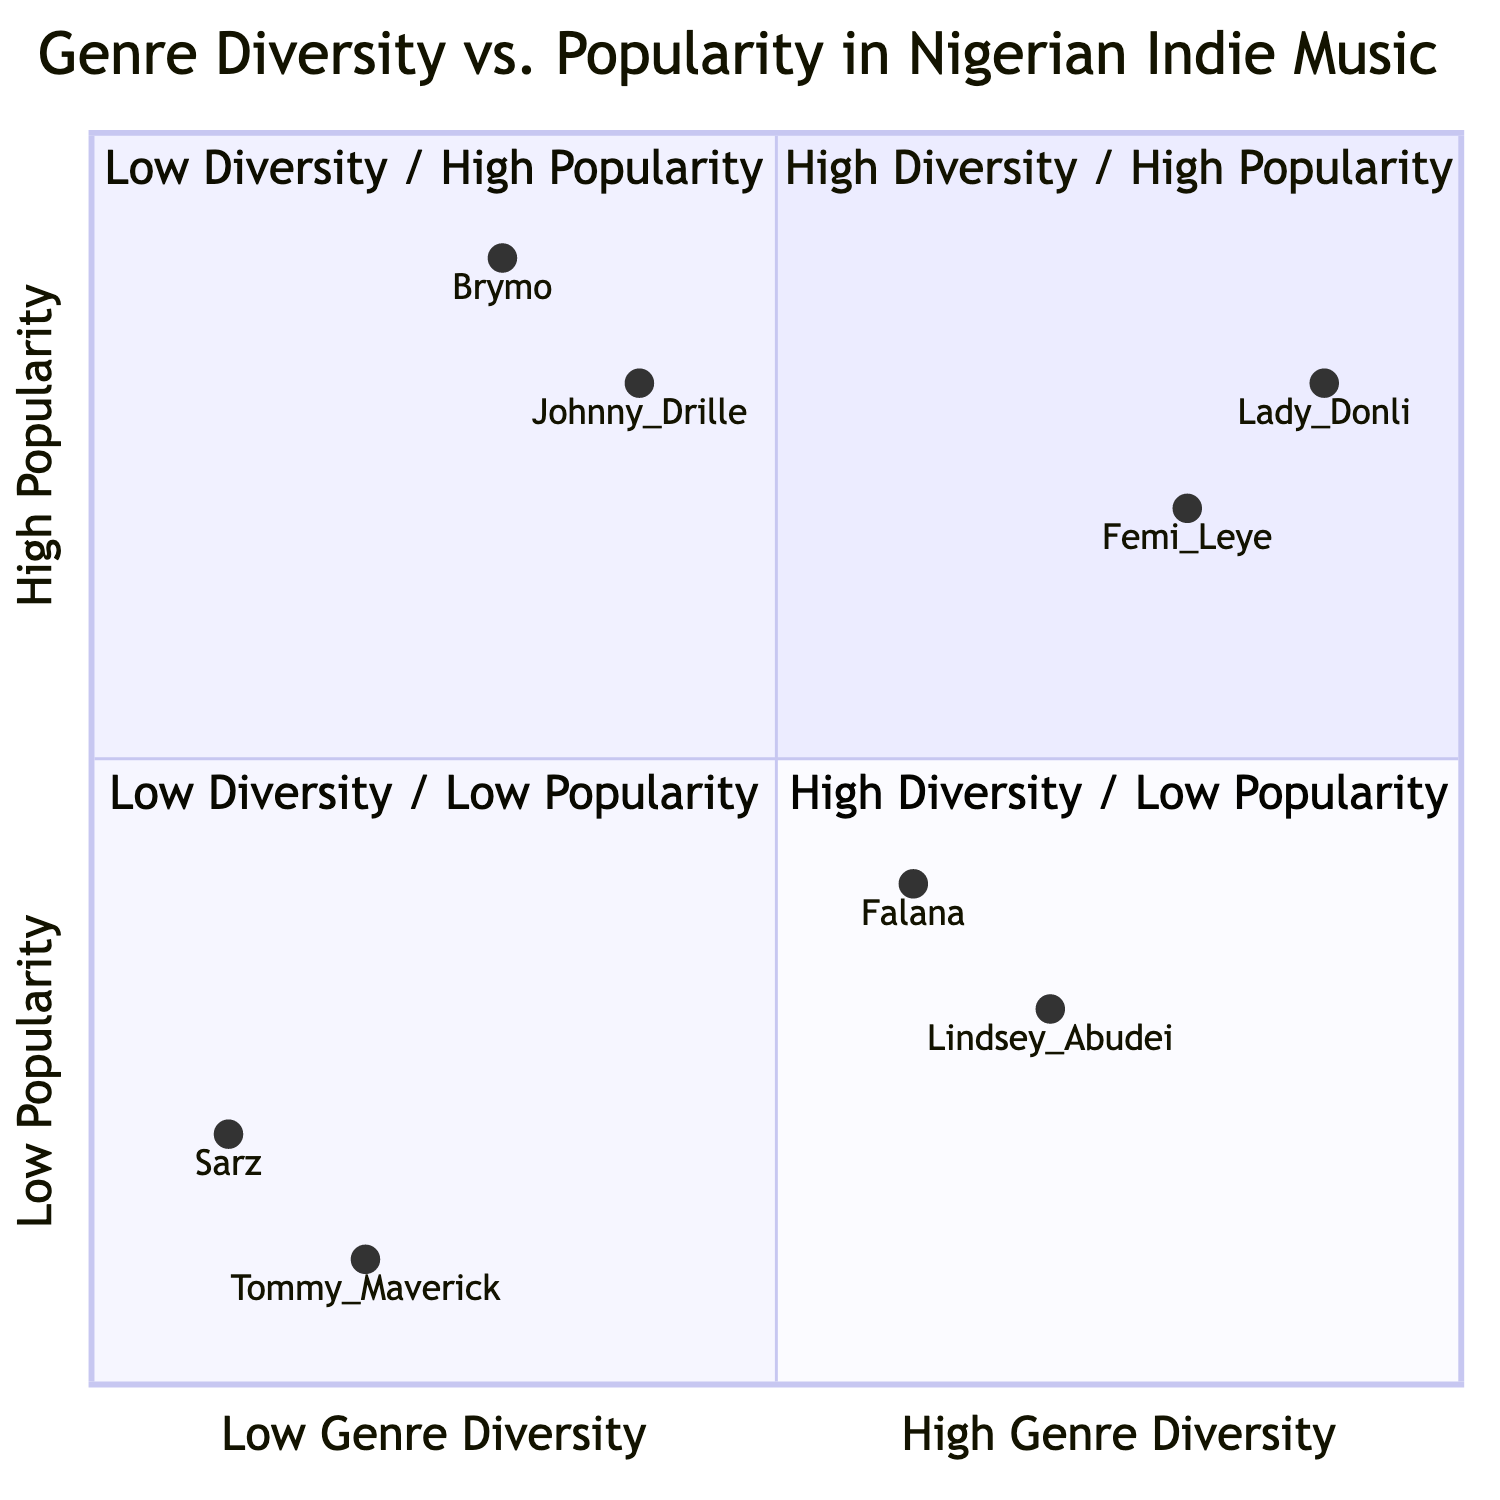What artist falls in the High Genre Diversity / High Popularity quadrant? The High Genre Diversity / High Popularity quadrant contains both Femi Leye and Lady Donli. The question specifically asks for one artist, and either can be chosen as they both meet the criteria.
Answer: Femi Leye Which age group is represented the most in the Low Genre Diversity / Low Popularity quadrant? In the Low Genre Diversity / Low Popularity quadrant, both artists, Sarz and Tommy Maverick, belong to the age group 35-44 and 25-34 respectively. Comparing the age groups, there is one member from 25-34 and one from 35-44. Therefore, no one age group is singled out, making it an equal representation.
Answer: 25-34 and 35-44 How many artists are in the Low Popularity category? The Low Popularity category includes artists from the Low Genre Diversity / Low Popularity and Low Diversity / High Popularity quadrants. We have Sarz, Tommy Maverick from the Low Popularity quadrant and Brymo, Johnny Drille from the Low Popularity quadrant. This results in a total of four artists categorized under Low Popularity.
Answer: Four Which artist in the High Genre Diversity / Low Popularity quadrant is associated with Acoustic genre? The High Genre Diversity / Low Popularity quadrant includes Lindsy Abudei, who is associated with Alternative Rock, Soul, and Jazz, and Falana, who is associated with Acoustic, Soul, and Folk. Since Falana specifically has Acoustic as one of the genres, the answer is clear.
Answer: Falana What is the most popular genre among the artists in the Low Genre Diversity / High Popularity quadrant? The Low Genre Diversity / High Popularity quadrant includes Brymo with Afrobeat and Soul genres, and Johnny Drille with Folk and Afrobeat. The fact that Afrobeat appears for both artists indicates it may be the most popular genre in that category. Thus, Afrobeat is confirmed as the most prevalent among them.
Answer: Afrobeat 